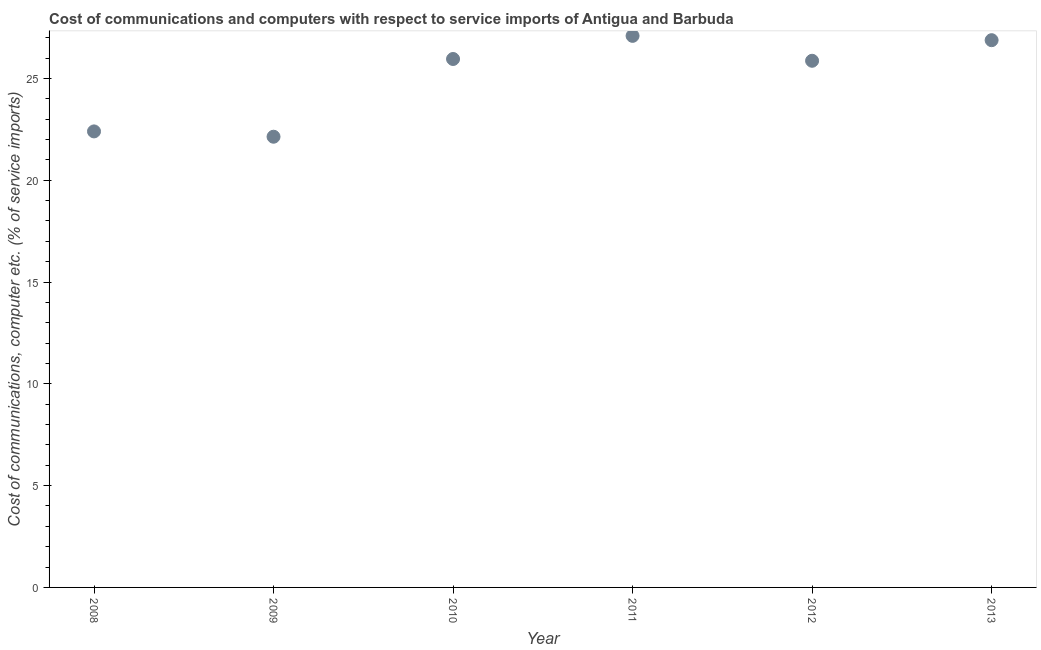What is the cost of communications and computer in 2012?
Offer a terse response. 25.87. Across all years, what is the maximum cost of communications and computer?
Offer a terse response. 27.09. Across all years, what is the minimum cost of communications and computer?
Offer a very short reply. 22.14. In which year was the cost of communications and computer maximum?
Give a very brief answer. 2011. In which year was the cost of communications and computer minimum?
Give a very brief answer. 2009. What is the sum of the cost of communications and computer?
Give a very brief answer. 150.32. What is the difference between the cost of communications and computer in 2008 and 2012?
Offer a terse response. -3.47. What is the average cost of communications and computer per year?
Give a very brief answer. 25.05. What is the median cost of communications and computer?
Provide a short and direct response. 25.91. Do a majority of the years between 2011 and 2010 (inclusive) have cost of communications and computer greater than 19 %?
Ensure brevity in your answer.  No. What is the ratio of the cost of communications and computer in 2009 to that in 2011?
Provide a succinct answer. 0.82. What is the difference between the highest and the second highest cost of communications and computer?
Keep it short and to the point. 0.21. Is the sum of the cost of communications and computer in 2009 and 2011 greater than the maximum cost of communications and computer across all years?
Give a very brief answer. Yes. What is the difference between the highest and the lowest cost of communications and computer?
Provide a succinct answer. 4.95. In how many years, is the cost of communications and computer greater than the average cost of communications and computer taken over all years?
Offer a terse response. 4. Does the cost of communications and computer monotonically increase over the years?
Provide a short and direct response. No. How many years are there in the graph?
Provide a short and direct response. 6. Are the values on the major ticks of Y-axis written in scientific E-notation?
Your response must be concise. No. Does the graph contain grids?
Offer a very short reply. No. What is the title of the graph?
Provide a succinct answer. Cost of communications and computers with respect to service imports of Antigua and Barbuda. What is the label or title of the X-axis?
Your answer should be very brief. Year. What is the label or title of the Y-axis?
Keep it short and to the point. Cost of communications, computer etc. (% of service imports). What is the Cost of communications, computer etc. (% of service imports) in 2008?
Make the answer very short. 22.4. What is the Cost of communications, computer etc. (% of service imports) in 2009?
Offer a terse response. 22.14. What is the Cost of communications, computer etc. (% of service imports) in 2010?
Provide a short and direct response. 25.95. What is the Cost of communications, computer etc. (% of service imports) in 2011?
Make the answer very short. 27.09. What is the Cost of communications, computer etc. (% of service imports) in 2012?
Give a very brief answer. 25.87. What is the Cost of communications, computer etc. (% of service imports) in 2013?
Offer a terse response. 26.88. What is the difference between the Cost of communications, computer etc. (% of service imports) in 2008 and 2009?
Your answer should be compact. 0.26. What is the difference between the Cost of communications, computer etc. (% of service imports) in 2008 and 2010?
Keep it short and to the point. -3.56. What is the difference between the Cost of communications, computer etc. (% of service imports) in 2008 and 2011?
Your answer should be very brief. -4.69. What is the difference between the Cost of communications, computer etc. (% of service imports) in 2008 and 2012?
Provide a succinct answer. -3.47. What is the difference between the Cost of communications, computer etc. (% of service imports) in 2008 and 2013?
Provide a succinct answer. -4.48. What is the difference between the Cost of communications, computer etc. (% of service imports) in 2009 and 2010?
Keep it short and to the point. -3.82. What is the difference between the Cost of communications, computer etc. (% of service imports) in 2009 and 2011?
Your answer should be very brief. -4.95. What is the difference between the Cost of communications, computer etc. (% of service imports) in 2009 and 2012?
Keep it short and to the point. -3.73. What is the difference between the Cost of communications, computer etc. (% of service imports) in 2009 and 2013?
Offer a terse response. -4.74. What is the difference between the Cost of communications, computer etc. (% of service imports) in 2010 and 2011?
Your answer should be very brief. -1.14. What is the difference between the Cost of communications, computer etc. (% of service imports) in 2010 and 2012?
Provide a succinct answer. 0.09. What is the difference between the Cost of communications, computer etc. (% of service imports) in 2010 and 2013?
Make the answer very short. -0.92. What is the difference between the Cost of communications, computer etc. (% of service imports) in 2011 and 2012?
Give a very brief answer. 1.22. What is the difference between the Cost of communications, computer etc. (% of service imports) in 2011 and 2013?
Provide a succinct answer. 0.21. What is the difference between the Cost of communications, computer etc. (% of service imports) in 2012 and 2013?
Give a very brief answer. -1.01. What is the ratio of the Cost of communications, computer etc. (% of service imports) in 2008 to that in 2009?
Keep it short and to the point. 1.01. What is the ratio of the Cost of communications, computer etc. (% of service imports) in 2008 to that in 2010?
Make the answer very short. 0.86. What is the ratio of the Cost of communications, computer etc. (% of service imports) in 2008 to that in 2011?
Your answer should be very brief. 0.83. What is the ratio of the Cost of communications, computer etc. (% of service imports) in 2008 to that in 2012?
Your answer should be compact. 0.87. What is the ratio of the Cost of communications, computer etc. (% of service imports) in 2008 to that in 2013?
Give a very brief answer. 0.83. What is the ratio of the Cost of communications, computer etc. (% of service imports) in 2009 to that in 2010?
Provide a short and direct response. 0.85. What is the ratio of the Cost of communications, computer etc. (% of service imports) in 2009 to that in 2011?
Give a very brief answer. 0.82. What is the ratio of the Cost of communications, computer etc. (% of service imports) in 2009 to that in 2012?
Your response must be concise. 0.86. What is the ratio of the Cost of communications, computer etc. (% of service imports) in 2009 to that in 2013?
Offer a very short reply. 0.82. What is the ratio of the Cost of communications, computer etc. (% of service imports) in 2010 to that in 2011?
Ensure brevity in your answer.  0.96. What is the ratio of the Cost of communications, computer etc. (% of service imports) in 2011 to that in 2012?
Offer a very short reply. 1.05. 